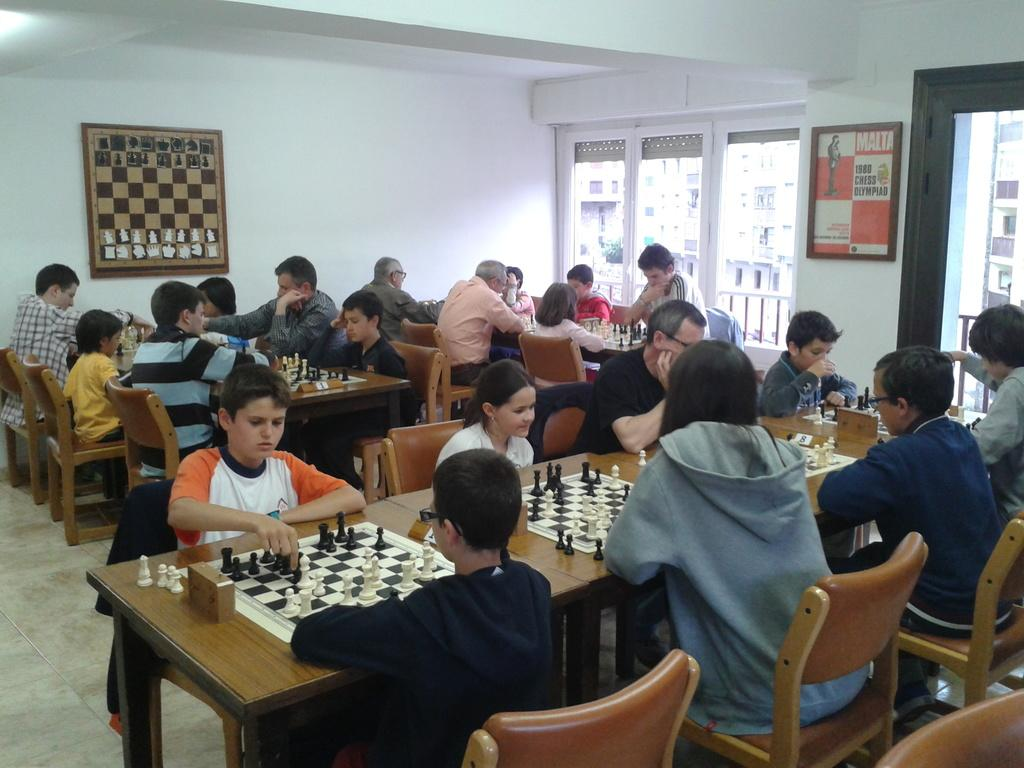What is the color of the wall in the image? The wall in the image is white. What can be seen on the wall? There is a window in the image. What is hanging on the wall? There is a banner in the image. What are the people in the image doing? The people are sitting on chairs in the image. What furniture is present in the image? There are tables in the image. What is on one of the tables? There is a chess board on one of the tables. What else is on one of the tables? There are coins on one of the tables. What type of plastic is used to make the key in the image? There is no key present in the image, so it is not possible to determine the type of plastic used. 